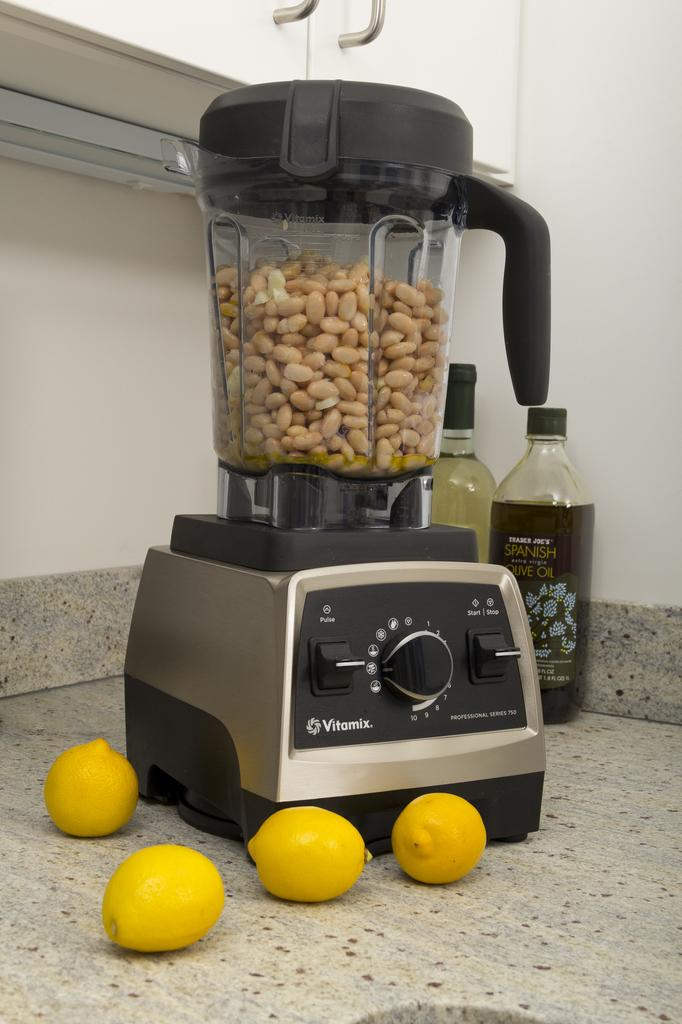Provide a one-sentence caption for the provided image. A professional series 750 blender full of nuts sitting on a marble counter surrounded by lemons. 